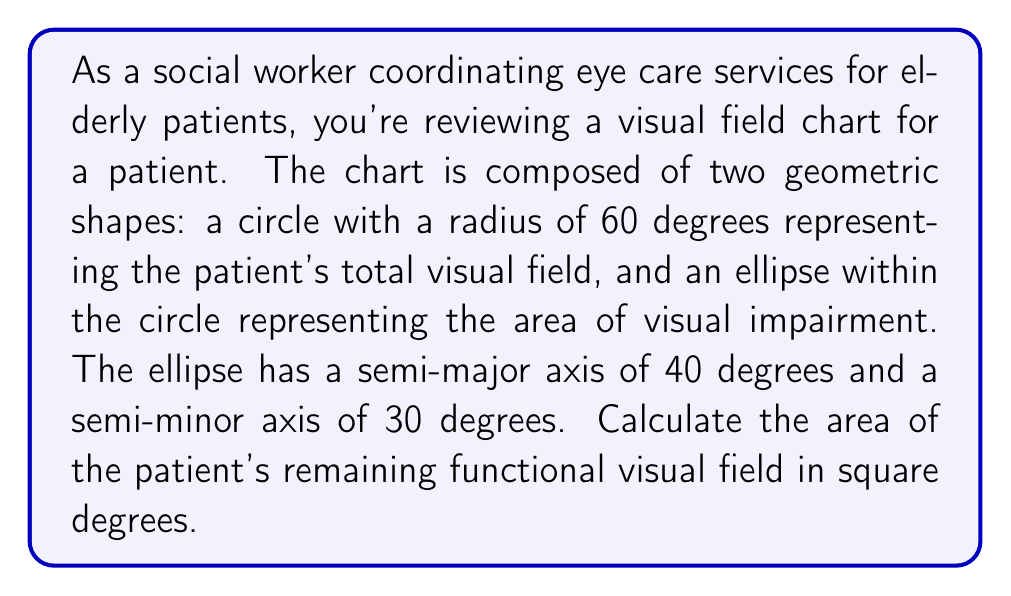Can you answer this question? To solve this problem, we need to follow these steps:

1. Calculate the area of the entire visual field (circle):
   $$A_{circle} = \pi r^2$$
   $$A_{circle} = \pi (60°)^2 = 3600\pi \text{ square degrees}$$

2. Calculate the area of the visual impairment (ellipse):
   $$A_{ellipse} = \pi ab$$
   where $a$ is the semi-major axis and $b$ is the semi-minor axis
   $$A_{ellipse} = \pi (40°)(30°) = 1200\pi \text{ square degrees}$$

3. Calculate the remaining functional visual field by subtracting the ellipse area from the circle area:
   $$A_{functional} = A_{circle} - A_{ellipse}$$
   $$A_{functional} = 3600\pi - 1200\pi = 2400\pi \text{ square degrees}$$

[asy]
import geometry;

size(200);
filldraw(circle((0,0),60), palegreen);
filldraw(ellipse((0,0),40,30), red+opacity(0.5));
draw((-70,0)--(70,0), arrow=Arrow(TeXHead));
draw((0,-70)--(0,70), arrow=Arrow(TeXHead));
label("60°", (60,0), E);
label("40°", (40,0), SE);
label("30°", (0,30), NW);
[/asy]

The green area in the diagram represents the functional visual field.
Answer: The area of the patient's remaining functional visual field is $2400\pi \text{ square degrees}$. 